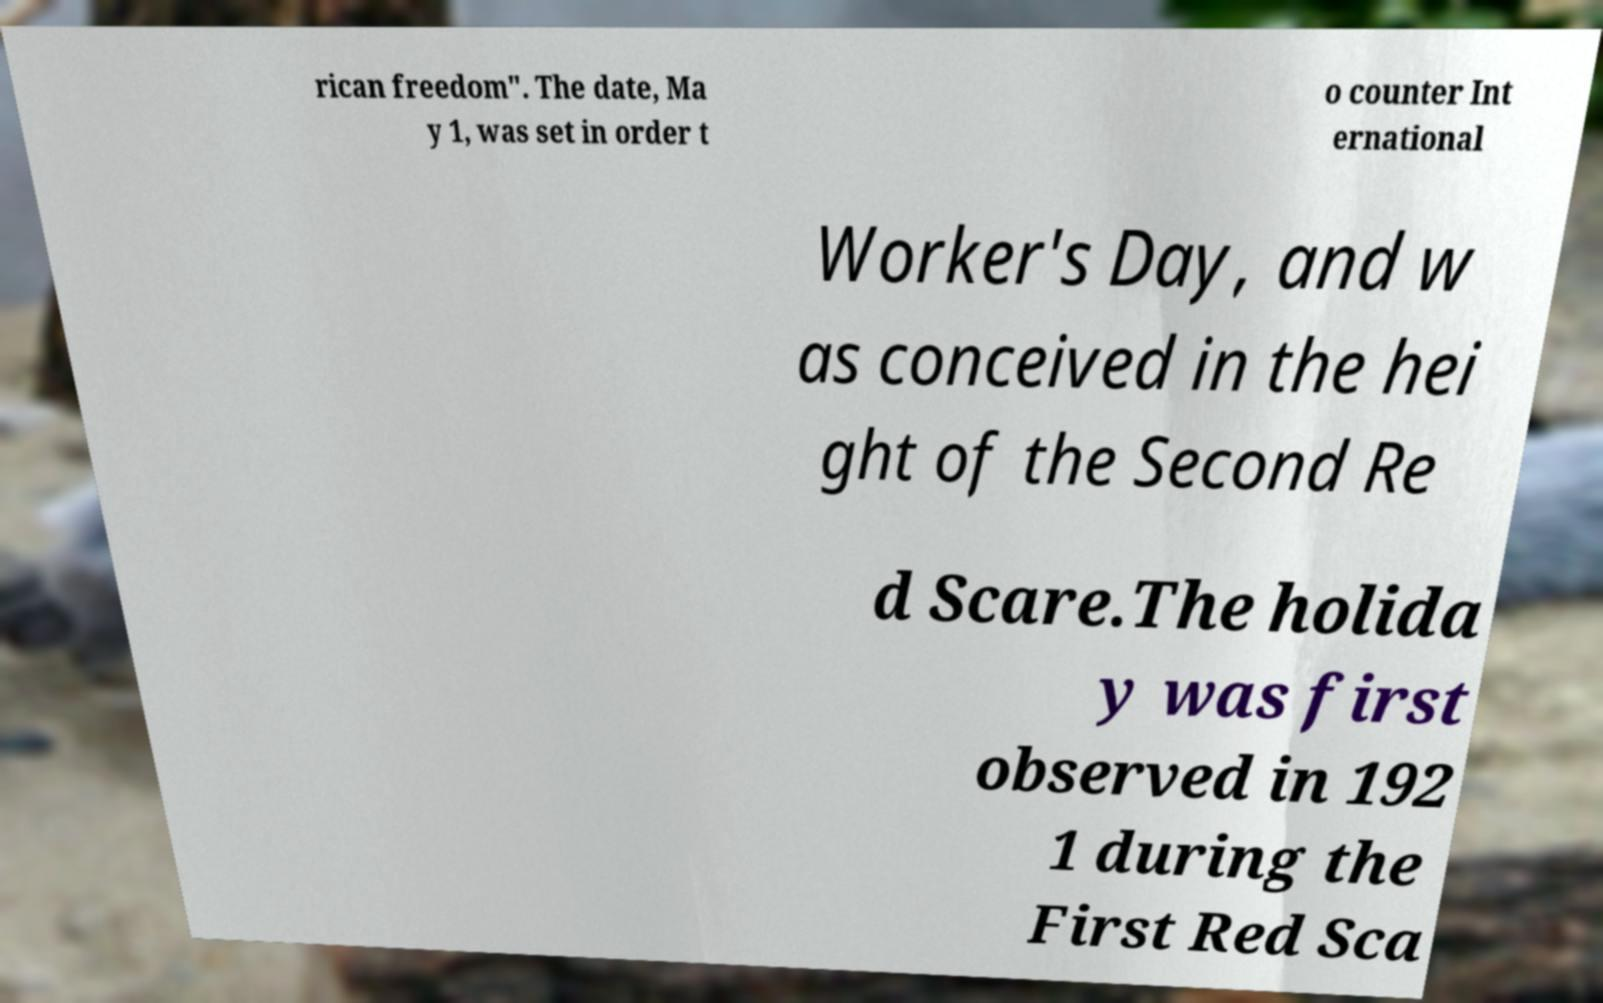For documentation purposes, I need the text within this image transcribed. Could you provide that? rican freedom". The date, Ma y 1, was set in order t o counter Int ernational Worker's Day, and w as conceived in the hei ght of the Second Re d Scare.The holida y was first observed in 192 1 during the First Red Sca 